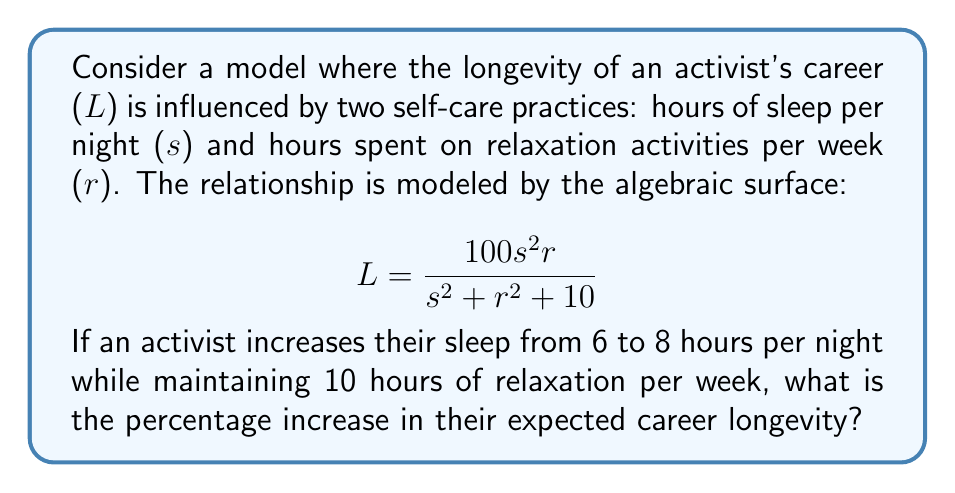What is the answer to this math problem? Let's approach this step-by-step:

1) First, we need to calculate the longevity (L) for both scenarios:

   Scenario 1: s = 6, r = 10
   Scenario 2: s = 8, r = 10

2) For Scenario 1:
   $$ L_1 = \frac{100(6^2)(10)}{6^2 + 10^2 + 10} = \frac{3600}{136} \approx 26.47 $$

3) For Scenario 2:
   $$ L_2 = \frac{100(8^2)(10)}{8^2 + 10^2 + 10} = \frac{6400}{174} \approx 36.78 $$

4) To calculate the percentage increase, we use the formula:
   $$ \text{Percentage Increase} = \frac{\text{Increase}}{\text{Original Value}} \times 100\% $$

5) In this case:
   $$ \text{Percentage Increase} = \frac{36.78 - 26.47}{26.47} \times 100\% \approx 38.95\% $$

6) Rounding to the nearest whole percentage:
   $$ \text{Percentage Increase} \approx 39\% $$
Answer: 39% 